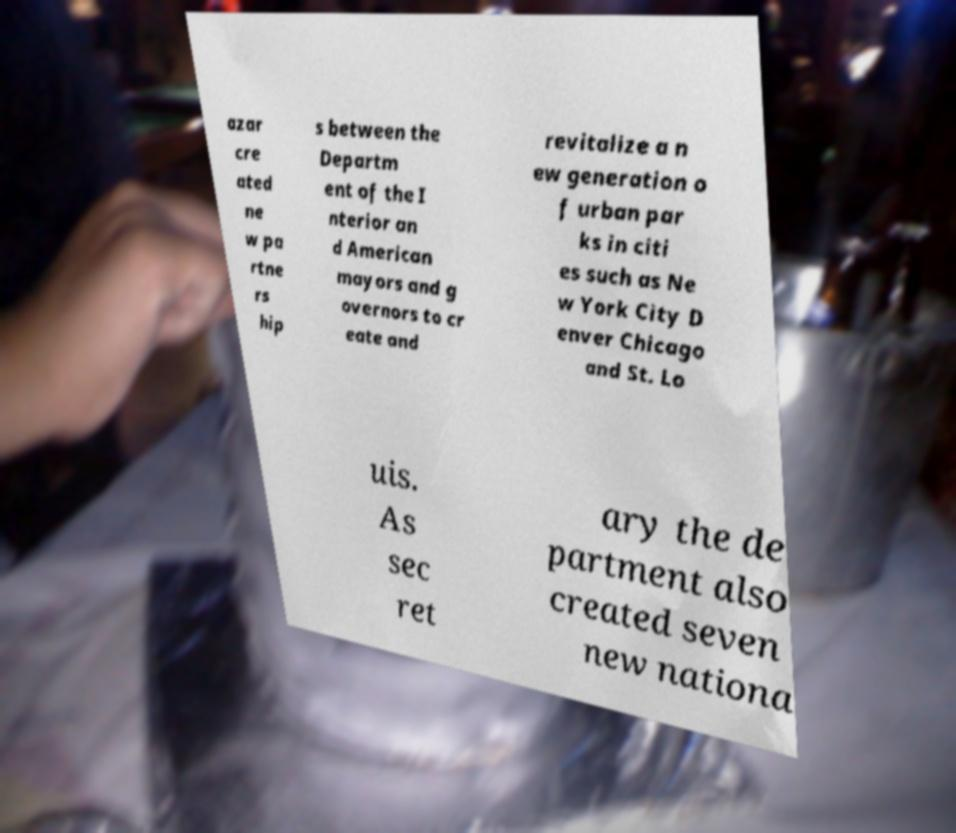Could you assist in decoding the text presented in this image and type it out clearly? azar cre ated ne w pa rtne rs hip s between the Departm ent of the I nterior an d American mayors and g overnors to cr eate and revitalize a n ew generation o f urban par ks in citi es such as Ne w York City D enver Chicago and St. Lo uis. As sec ret ary the de partment also created seven new nationa 